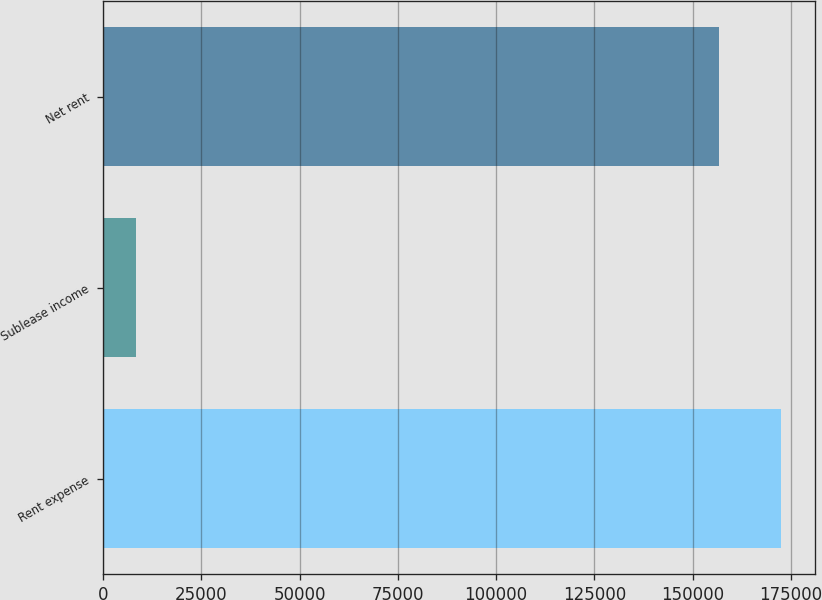<chart> <loc_0><loc_0><loc_500><loc_500><bar_chart><fcel>Rent expense<fcel>Sublease income<fcel>Net rent<nl><fcel>172501<fcel>8402<fcel>156819<nl></chart> 